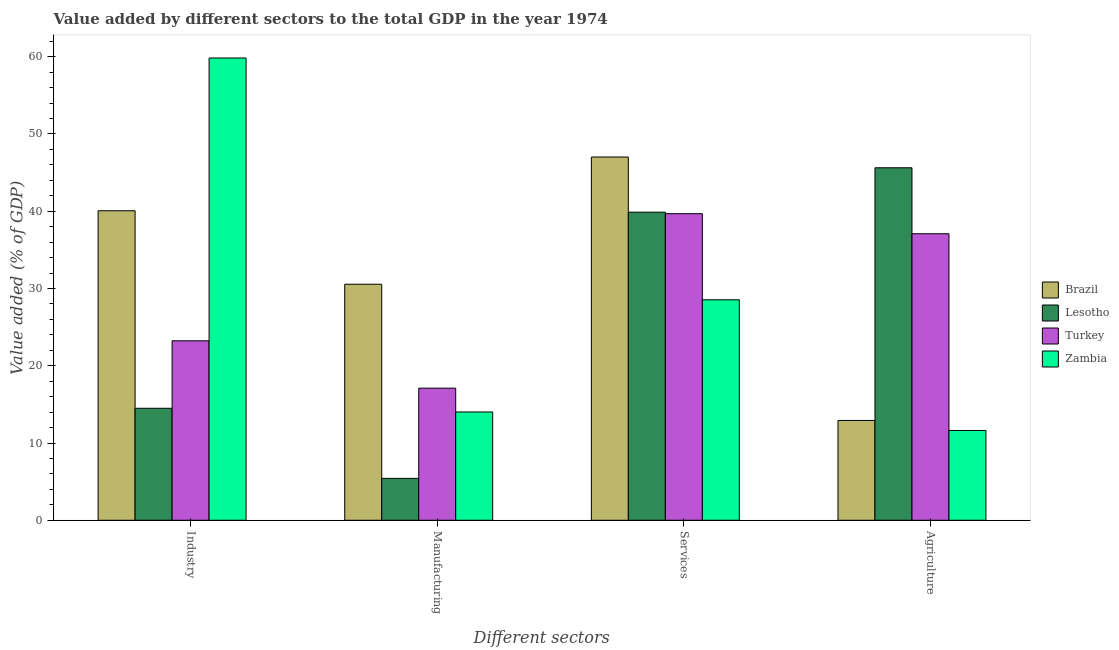Are the number of bars per tick equal to the number of legend labels?
Make the answer very short. Yes. How many bars are there on the 2nd tick from the right?
Give a very brief answer. 4. What is the label of the 4th group of bars from the left?
Offer a very short reply. Agriculture. What is the value added by industrial sector in Zambia?
Your answer should be very brief. 59.84. Across all countries, what is the maximum value added by agricultural sector?
Make the answer very short. 45.63. Across all countries, what is the minimum value added by services sector?
Your answer should be very brief. 28.54. In which country was the value added by services sector minimum?
Make the answer very short. Zambia. What is the total value added by manufacturing sector in the graph?
Offer a very short reply. 67.09. What is the difference between the value added by industrial sector in Lesotho and that in Zambia?
Keep it short and to the point. -45.34. What is the difference between the value added by agricultural sector in Zambia and the value added by industrial sector in Brazil?
Make the answer very short. -28.44. What is the average value added by industrial sector per country?
Give a very brief answer. 34.41. What is the difference between the value added by services sector and value added by agricultural sector in Lesotho?
Your response must be concise. -5.75. In how many countries, is the value added by agricultural sector greater than 6 %?
Offer a very short reply. 4. What is the ratio of the value added by services sector in Lesotho to that in Brazil?
Provide a short and direct response. 0.85. Is the value added by services sector in Brazil less than that in Zambia?
Your answer should be very brief. No. What is the difference between the highest and the second highest value added by agricultural sector?
Provide a short and direct response. 8.54. What is the difference between the highest and the lowest value added by manufacturing sector?
Provide a succinct answer. 25.13. In how many countries, is the value added by services sector greater than the average value added by services sector taken over all countries?
Provide a short and direct response. 3. Is it the case that in every country, the sum of the value added by agricultural sector and value added by manufacturing sector is greater than the sum of value added by industrial sector and value added by services sector?
Provide a succinct answer. No. What does the 4th bar from the left in Agriculture represents?
Give a very brief answer. Zambia. What does the 3rd bar from the right in Services represents?
Offer a very short reply. Lesotho. How many countries are there in the graph?
Make the answer very short. 4. Does the graph contain any zero values?
Make the answer very short. No. What is the title of the graph?
Offer a terse response. Value added by different sectors to the total GDP in the year 1974. What is the label or title of the X-axis?
Offer a terse response. Different sectors. What is the label or title of the Y-axis?
Provide a succinct answer. Value added (% of GDP). What is the Value added (% of GDP) of Brazil in Industry?
Keep it short and to the point. 40.06. What is the Value added (% of GDP) of Lesotho in Industry?
Ensure brevity in your answer.  14.5. What is the Value added (% of GDP) of Turkey in Industry?
Your answer should be compact. 23.23. What is the Value added (% of GDP) in Zambia in Industry?
Your response must be concise. 59.84. What is the Value added (% of GDP) of Brazil in Manufacturing?
Give a very brief answer. 30.55. What is the Value added (% of GDP) in Lesotho in Manufacturing?
Provide a short and direct response. 5.42. What is the Value added (% of GDP) of Turkey in Manufacturing?
Ensure brevity in your answer.  17.1. What is the Value added (% of GDP) of Zambia in Manufacturing?
Provide a short and direct response. 14.02. What is the Value added (% of GDP) of Brazil in Services?
Give a very brief answer. 47.02. What is the Value added (% of GDP) in Lesotho in Services?
Offer a very short reply. 39.88. What is the Value added (% of GDP) in Turkey in Services?
Keep it short and to the point. 39.68. What is the Value added (% of GDP) in Zambia in Services?
Make the answer very short. 28.54. What is the Value added (% of GDP) of Brazil in Agriculture?
Your answer should be very brief. 12.92. What is the Value added (% of GDP) of Lesotho in Agriculture?
Make the answer very short. 45.63. What is the Value added (% of GDP) in Turkey in Agriculture?
Provide a succinct answer. 37.09. What is the Value added (% of GDP) in Zambia in Agriculture?
Ensure brevity in your answer.  11.63. Across all Different sectors, what is the maximum Value added (% of GDP) of Brazil?
Offer a terse response. 47.02. Across all Different sectors, what is the maximum Value added (% of GDP) in Lesotho?
Ensure brevity in your answer.  45.63. Across all Different sectors, what is the maximum Value added (% of GDP) in Turkey?
Provide a short and direct response. 39.68. Across all Different sectors, what is the maximum Value added (% of GDP) in Zambia?
Ensure brevity in your answer.  59.84. Across all Different sectors, what is the minimum Value added (% of GDP) of Brazil?
Keep it short and to the point. 12.92. Across all Different sectors, what is the minimum Value added (% of GDP) of Lesotho?
Your response must be concise. 5.42. Across all Different sectors, what is the minimum Value added (% of GDP) in Turkey?
Your response must be concise. 17.1. Across all Different sectors, what is the minimum Value added (% of GDP) of Zambia?
Keep it short and to the point. 11.63. What is the total Value added (% of GDP) in Brazil in the graph?
Offer a very short reply. 130.55. What is the total Value added (% of GDP) in Lesotho in the graph?
Ensure brevity in your answer.  105.42. What is the total Value added (% of GDP) of Turkey in the graph?
Your response must be concise. 117.1. What is the total Value added (% of GDP) in Zambia in the graph?
Your answer should be very brief. 114.02. What is the difference between the Value added (% of GDP) of Brazil in Industry and that in Manufacturing?
Your response must be concise. 9.51. What is the difference between the Value added (% of GDP) in Lesotho in Industry and that in Manufacturing?
Give a very brief answer. 9.07. What is the difference between the Value added (% of GDP) of Turkey in Industry and that in Manufacturing?
Your answer should be very brief. 6.13. What is the difference between the Value added (% of GDP) of Zambia in Industry and that in Manufacturing?
Provide a short and direct response. 45.82. What is the difference between the Value added (% of GDP) of Brazil in Industry and that in Services?
Keep it short and to the point. -6.95. What is the difference between the Value added (% of GDP) in Lesotho in Industry and that in Services?
Offer a very short reply. -25.38. What is the difference between the Value added (% of GDP) of Turkey in Industry and that in Services?
Offer a terse response. -16.46. What is the difference between the Value added (% of GDP) in Zambia in Industry and that in Services?
Provide a short and direct response. 31.3. What is the difference between the Value added (% of GDP) in Brazil in Industry and that in Agriculture?
Keep it short and to the point. 27.14. What is the difference between the Value added (% of GDP) in Lesotho in Industry and that in Agriculture?
Offer a very short reply. -31.13. What is the difference between the Value added (% of GDP) in Turkey in Industry and that in Agriculture?
Your response must be concise. -13.86. What is the difference between the Value added (% of GDP) of Zambia in Industry and that in Agriculture?
Offer a terse response. 48.21. What is the difference between the Value added (% of GDP) in Brazil in Manufacturing and that in Services?
Make the answer very short. -16.46. What is the difference between the Value added (% of GDP) in Lesotho in Manufacturing and that in Services?
Your response must be concise. -34.45. What is the difference between the Value added (% of GDP) of Turkey in Manufacturing and that in Services?
Give a very brief answer. -22.58. What is the difference between the Value added (% of GDP) of Zambia in Manufacturing and that in Services?
Your response must be concise. -14.52. What is the difference between the Value added (% of GDP) of Brazil in Manufacturing and that in Agriculture?
Give a very brief answer. 17.63. What is the difference between the Value added (% of GDP) of Lesotho in Manufacturing and that in Agriculture?
Give a very brief answer. -40.2. What is the difference between the Value added (% of GDP) in Turkey in Manufacturing and that in Agriculture?
Your answer should be very brief. -19.99. What is the difference between the Value added (% of GDP) of Zambia in Manufacturing and that in Agriculture?
Your response must be concise. 2.39. What is the difference between the Value added (% of GDP) in Brazil in Services and that in Agriculture?
Your response must be concise. 34.1. What is the difference between the Value added (% of GDP) in Lesotho in Services and that in Agriculture?
Make the answer very short. -5.75. What is the difference between the Value added (% of GDP) of Turkey in Services and that in Agriculture?
Offer a terse response. 2.6. What is the difference between the Value added (% of GDP) in Zambia in Services and that in Agriculture?
Provide a succinct answer. 16.91. What is the difference between the Value added (% of GDP) of Brazil in Industry and the Value added (% of GDP) of Lesotho in Manufacturing?
Give a very brief answer. 34.64. What is the difference between the Value added (% of GDP) of Brazil in Industry and the Value added (% of GDP) of Turkey in Manufacturing?
Make the answer very short. 22.96. What is the difference between the Value added (% of GDP) in Brazil in Industry and the Value added (% of GDP) in Zambia in Manufacturing?
Your answer should be very brief. 26.05. What is the difference between the Value added (% of GDP) in Lesotho in Industry and the Value added (% of GDP) in Turkey in Manufacturing?
Keep it short and to the point. -2.6. What is the difference between the Value added (% of GDP) in Lesotho in Industry and the Value added (% of GDP) in Zambia in Manufacturing?
Provide a succinct answer. 0.48. What is the difference between the Value added (% of GDP) of Turkey in Industry and the Value added (% of GDP) of Zambia in Manufacturing?
Your response must be concise. 9.21. What is the difference between the Value added (% of GDP) of Brazil in Industry and the Value added (% of GDP) of Lesotho in Services?
Make the answer very short. 0.18. What is the difference between the Value added (% of GDP) in Brazil in Industry and the Value added (% of GDP) in Turkey in Services?
Offer a very short reply. 0.38. What is the difference between the Value added (% of GDP) in Brazil in Industry and the Value added (% of GDP) in Zambia in Services?
Offer a very short reply. 11.53. What is the difference between the Value added (% of GDP) in Lesotho in Industry and the Value added (% of GDP) in Turkey in Services?
Ensure brevity in your answer.  -25.19. What is the difference between the Value added (% of GDP) of Lesotho in Industry and the Value added (% of GDP) of Zambia in Services?
Ensure brevity in your answer.  -14.04. What is the difference between the Value added (% of GDP) of Turkey in Industry and the Value added (% of GDP) of Zambia in Services?
Your response must be concise. -5.31. What is the difference between the Value added (% of GDP) of Brazil in Industry and the Value added (% of GDP) of Lesotho in Agriculture?
Your answer should be very brief. -5.56. What is the difference between the Value added (% of GDP) in Brazil in Industry and the Value added (% of GDP) in Turkey in Agriculture?
Provide a succinct answer. 2.98. What is the difference between the Value added (% of GDP) of Brazil in Industry and the Value added (% of GDP) of Zambia in Agriculture?
Make the answer very short. 28.44. What is the difference between the Value added (% of GDP) of Lesotho in Industry and the Value added (% of GDP) of Turkey in Agriculture?
Provide a short and direct response. -22.59. What is the difference between the Value added (% of GDP) of Lesotho in Industry and the Value added (% of GDP) of Zambia in Agriculture?
Keep it short and to the point. 2.87. What is the difference between the Value added (% of GDP) in Turkey in Industry and the Value added (% of GDP) in Zambia in Agriculture?
Your response must be concise. 11.6. What is the difference between the Value added (% of GDP) of Brazil in Manufacturing and the Value added (% of GDP) of Lesotho in Services?
Provide a short and direct response. -9.33. What is the difference between the Value added (% of GDP) in Brazil in Manufacturing and the Value added (% of GDP) in Turkey in Services?
Provide a succinct answer. -9.13. What is the difference between the Value added (% of GDP) in Brazil in Manufacturing and the Value added (% of GDP) in Zambia in Services?
Your answer should be compact. 2.02. What is the difference between the Value added (% of GDP) of Lesotho in Manufacturing and the Value added (% of GDP) of Turkey in Services?
Your answer should be very brief. -34.26. What is the difference between the Value added (% of GDP) in Lesotho in Manufacturing and the Value added (% of GDP) in Zambia in Services?
Your answer should be compact. -23.11. What is the difference between the Value added (% of GDP) in Turkey in Manufacturing and the Value added (% of GDP) in Zambia in Services?
Give a very brief answer. -11.44. What is the difference between the Value added (% of GDP) of Brazil in Manufacturing and the Value added (% of GDP) of Lesotho in Agriculture?
Make the answer very short. -15.07. What is the difference between the Value added (% of GDP) in Brazil in Manufacturing and the Value added (% of GDP) in Turkey in Agriculture?
Provide a succinct answer. -6.53. What is the difference between the Value added (% of GDP) of Brazil in Manufacturing and the Value added (% of GDP) of Zambia in Agriculture?
Offer a terse response. 18.93. What is the difference between the Value added (% of GDP) in Lesotho in Manufacturing and the Value added (% of GDP) in Turkey in Agriculture?
Ensure brevity in your answer.  -31.66. What is the difference between the Value added (% of GDP) of Lesotho in Manufacturing and the Value added (% of GDP) of Zambia in Agriculture?
Give a very brief answer. -6.2. What is the difference between the Value added (% of GDP) in Turkey in Manufacturing and the Value added (% of GDP) in Zambia in Agriculture?
Keep it short and to the point. 5.47. What is the difference between the Value added (% of GDP) in Brazil in Services and the Value added (% of GDP) in Lesotho in Agriculture?
Make the answer very short. 1.39. What is the difference between the Value added (% of GDP) of Brazil in Services and the Value added (% of GDP) of Turkey in Agriculture?
Offer a terse response. 9.93. What is the difference between the Value added (% of GDP) in Brazil in Services and the Value added (% of GDP) in Zambia in Agriculture?
Keep it short and to the point. 35.39. What is the difference between the Value added (% of GDP) in Lesotho in Services and the Value added (% of GDP) in Turkey in Agriculture?
Make the answer very short. 2.79. What is the difference between the Value added (% of GDP) in Lesotho in Services and the Value added (% of GDP) in Zambia in Agriculture?
Your response must be concise. 28.25. What is the difference between the Value added (% of GDP) in Turkey in Services and the Value added (% of GDP) in Zambia in Agriculture?
Your answer should be compact. 28.06. What is the average Value added (% of GDP) of Brazil per Different sectors?
Provide a succinct answer. 32.64. What is the average Value added (% of GDP) of Lesotho per Different sectors?
Offer a terse response. 26.36. What is the average Value added (% of GDP) of Turkey per Different sectors?
Make the answer very short. 29.27. What is the average Value added (% of GDP) in Zambia per Different sectors?
Your response must be concise. 28.5. What is the difference between the Value added (% of GDP) in Brazil and Value added (% of GDP) in Lesotho in Industry?
Give a very brief answer. 25.57. What is the difference between the Value added (% of GDP) of Brazil and Value added (% of GDP) of Turkey in Industry?
Your response must be concise. 16.83. What is the difference between the Value added (% of GDP) in Brazil and Value added (% of GDP) in Zambia in Industry?
Keep it short and to the point. -19.77. What is the difference between the Value added (% of GDP) of Lesotho and Value added (% of GDP) of Turkey in Industry?
Your response must be concise. -8.73. What is the difference between the Value added (% of GDP) in Lesotho and Value added (% of GDP) in Zambia in Industry?
Ensure brevity in your answer.  -45.34. What is the difference between the Value added (% of GDP) in Turkey and Value added (% of GDP) in Zambia in Industry?
Keep it short and to the point. -36.61. What is the difference between the Value added (% of GDP) in Brazil and Value added (% of GDP) in Lesotho in Manufacturing?
Ensure brevity in your answer.  25.13. What is the difference between the Value added (% of GDP) in Brazil and Value added (% of GDP) in Turkey in Manufacturing?
Offer a very short reply. 13.45. What is the difference between the Value added (% of GDP) of Brazil and Value added (% of GDP) of Zambia in Manufacturing?
Your answer should be very brief. 16.53. What is the difference between the Value added (% of GDP) in Lesotho and Value added (% of GDP) in Turkey in Manufacturing?
Keep it short and to the point. -11.68. What is the difference between the Value added (% of GDP) in Lesotho and Value added (% of GDP) in Zambia in Manufacturing?
Give a very brief answer. -8.59. What is the difference between the Value added (% of GDP) of Turkey and Value added (% of GDP) of Zambia in Manufacturing?
Offer a terse response. 3.08. What is the difference between the Value added (% of GDP) in Brazil and Value added (% of GDP) in Lesotho in Services?
Ensure brevity in your answer.  7.14. What is the difference between the Value added (% of GDP) in Brazil and Value added (% of GDP) in Turkey in Services?
Make the answer very short. 7.33. What is the difference between the Value added (% of GDP) in Brazil and Value added (% of GDP) in Zambia in Services?
Your answer should be very brief. 18.48. What is the difference between the Value added (% of GDP) in Lesotho and Value added (% of GDP) in Turkey in Services?
Your answer should be very brief. 0.19. What is the difference between the Value added (% of GDP) in Lesotho and Value added (% of GDP) in Zambia in Services?
Provide a succinct answer. 11.34. What is the difference between the Value added (% of GDP) in Turkey and Value added (% of GDP) in Zambia in Services?
Keep it short and to the point. 11.15. What is the difference between the Value added (% of GDP) in Brazil and Value added (% of GDP) in Lesotho in Agriculture?
Offer a very short reply. -32.71. What is the difference between the Value added (% of GDP) of Brazil and Value added (% of GDP) of Turkey in Agriculture?
Give a very brief answer. -24.17. What is the difference between the Value added (% of GDP) in Brazil and Value added (% of GDP) in Zambia in Agriculture?
Your answer should be compact. 1.29. What is the difference between the Value added (% of GDP) of Lesotho and Value added (% of GDP) of Turkey in Agriculture?
Your response must be concise. 8.54. What is the difference between the Value added (% of GDP) of Lesotho and Value added (% of GDP) of Zambia in Agriculture?
Give a very brief answer. 34. What is the difference between the Value added (% of GDP) in Turkey and Value added (% of GDP) in Zambia in Agriculture?
Make the answer very short. 25.46. What is the ratio of the Value added (% of GDP) in Brazil in Industry to that in Manufacturing?
Your answer should be compact. 1.31. What is the ratio of the Value added (% of GDP) of Lesotho in Industry to that in Manufacturing?
Ensure brevity in your answer.  2.67. What is the ratio of the Value added (% of GDP) of Turkey in Industry to that in Manufacturing?
Make the answer very short. 1.36. What is the ratio of the Value added (% of GDP) of Zambia in Industry to that in Manufacturing?
Provide a short and direct response. 4.27. What is the ratio of the Value added (% of GDP) in Brazil in Industry to that in Services?
Your answer should be compact. 0.85. What is the ratio of the Value added (% of GDP) in Lesotho in Industry to that in Services?
Keep it short and to the point. 0.36. What is the ratio of the Value added (% of GDP) in Turkey in Industry to that in Services?
Your response must be concise. 0.59. What is the ratio of the Value added (% of GDP) in Zambia in Industry to that in Services?
Your answer should be very brief. 2.1. What is the ratio of the Value added (% of GDP) in Brazil in Industry to that in Agriculture?
Give a very brief answer. 3.1. What is the ratio of the Value added (% of GDP) of Lesotho in Industry to that in Agriculture?
Your answer should be compact. 0.32. What is the ratio of the Value added (% of GDP) of Turkey in Industry to that in Agriculture?
Your answer should be very brief. 0.63. What is the ratio of the Value added (% of GDP) of Zambia in Industry to that in Agriculture?
Your answer should be compact. 5.15. What is the ratio of the Value added (% of GDP) of Brazil in Manufacturing to that in Services?
Your answer should be compact. 0.65. What is the ratio of the Value added (% of GDP) in Lesotho in Manufacturing to that in Services?
Your answer should be compact. 0.14. What is the ratio of the Value added (% of GDP) in Turkey in Manufacturing to that in Services?
Provide a short and direct response. 0.43. What is the ratio of the Value added (% of GDP) in Zambia in Manufacturing to that in Services?
Ensure brevity in your answer.  0.49. What is the ratio of the Value added (% of GDP) of Brazil in Manufacturing to that in Agriculture?
Provide a short and direct response. 2.36. What is the ratio of the Value added (% of GDP) of Lesotho in Manufacturing to that in Agriculture?
Your response must be concise. 0.12. What is the ratio of the Value added (% of GDP) of Turkey in Manufacturing to that in Agriculture?
Ensure brevity in your answer.  0.46. What is the ratio of the Value added (% of GDP) of Zambia in Manufacturing to that in Agriculture?
Your response must be concise. 1.21. What is the ratio of the Value added (% of GDP) of Brazil in Services to that in Agriculture?
Keep it short and to the point. 3.64. What is the ratio of the Value added (% of GDP) in Lesotho in Services to that in Agriculture?
Your answer should be compact. 0.87. What is the ratio of the Value added (% of GDP) in Turkey in Services to that in Agriculture?
Offer a very short reply. 1.07. What is the ratio of the Value added (% of GDP) of Zambia in Services to that in Agriculture?
Your answer should be very brief. 2.45. What is the difference between the highest and the second highest Value added (% of GDP) in Brazil?
Provide a succinct answer. 6.95. What is the difference between the highest and the second highest Value added (% of GDP) of Lesotho?
Provide a short and direct response. 5.75. What is the difference between the highest and the second highest Value added (% of GDP) of Turkey?
Your answer should be very brief. 2.6. What is the difference between the highest and the second highest Value added (% of GDP) in Zambia?
Your response must be concise. 31.3. What is the difference between the highest and the lowest Value added (% of GDP) of Brazil?
Provide a succinct answer. 34.1. What is the difference between the highest and the lowest Value added (% of GDP) of Lesotho?
Give a very brief answer. 40.2. What is the difference between the highest and the lowest Value added (% of GDP) of Turkey?
Your response must be concise. 22.58. What is the difference between the highest and the lowest Value added (% of GDP) of Zambia?
Make the answer very short. 48.21. 